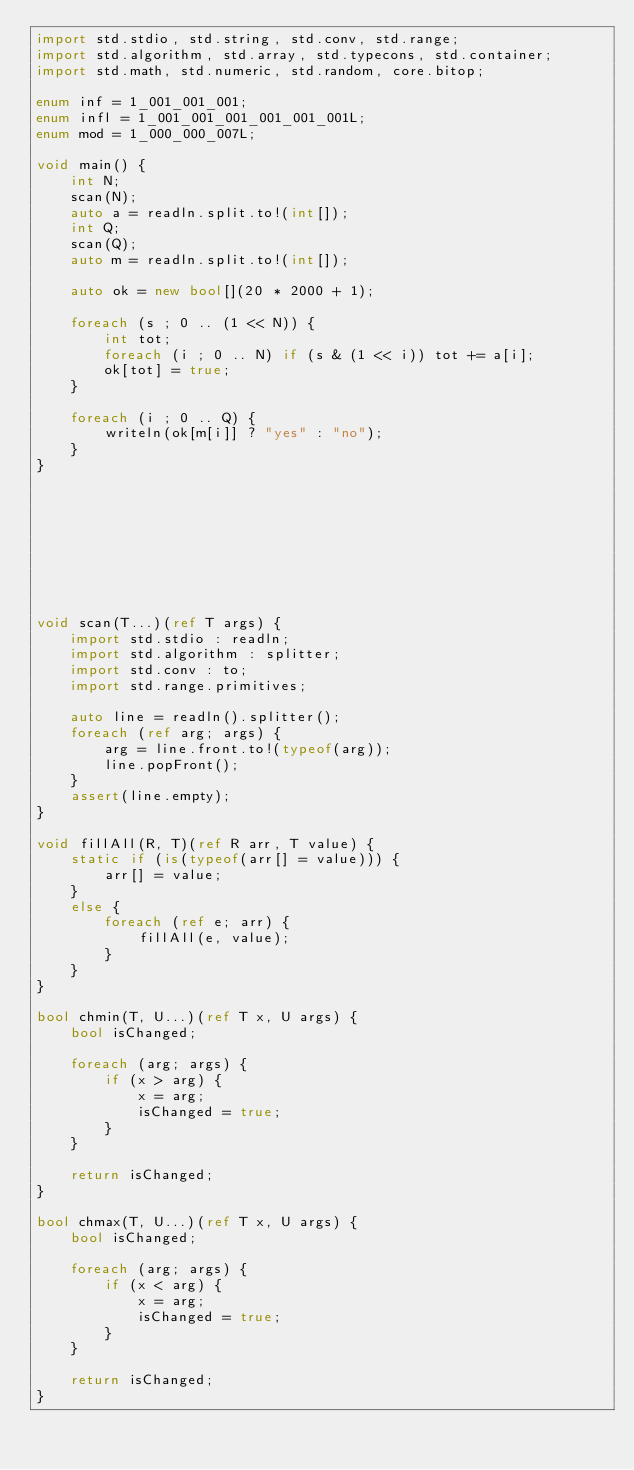<code> <loc_0><loc_0><loc_500><loc_500><_D_>import std.stdio, std.string, std.conv, std.range;
import std.algorithm, std.array, std.typecons, std.container;
import std.math, std.numeric, std.random, core.bitop;

enum inf = 1_001_001_001;
enum infl = 1_001_001_001_001_001_001L;
enum mod = 1_000_000_007L;

void main() {
    int N;
    scan(N);
    auto a = readln.split.to!(int[]);
    int Q;
    scan(Q);
    auto m = readln.split.to!(int[]);

    auto ok = new bool[](20 * 2000 + 1);

    foreach (s ; 0 .. (1 << N)) {
        int tot;
        foreach (i ; 0 .. N) if (s & (1 << i)) tot += a[i];
        ok[tot] = true;
    }

    foreach (i ; 0 .. Q) {
        writeln(ok[m[i]] ? "yes" : "no");
    }
}









void scan(T...)(ref T args) {
    import std.stdio : readln;
    import std.algorithm : splitter;
    import std.conv : to;
    import std.range.primitives;

    auto line = readln().splitter();
    foreach (ref arg; args) {
        arg = line.front.to!(typeof(arg));
        line.popFront();
    }
    assert(line.empty);
}

void fillAll(R, T)(ref R arr, T value) {
    static if (is(typeof(arr[] = value))) {
        arr[] = value;
    }
    else {
        foreach (ref e; arr) {
            fillAll(e, value);
        }
    }
}

bool chmin(T, U...)(ref T x, U args) {
    bool isChanged;

    foreach (arg; args) {
        if (x > arg) {
            x = arg;
            isChanged = true;
        }
    }

    return isChanged;
}

bool chmax(T, U...)(ref T x, U args) {
    bool isChanged;

    foreach (arg; args) {
        if (x < arg) {
            x = arg;
            isChanged = true;
        }
    }

    return isChanged;
}

</code> 